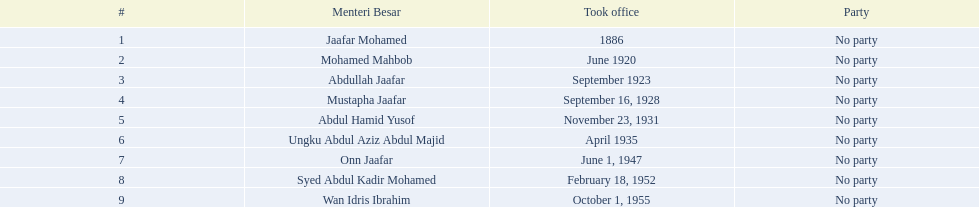What are all the people that were menteri besar of johor? Jaafar Mohamed, Mohamed Mahbob, Abdullah Jaafar, Mustapha Jaafar, Abdul Hamid Yusof, Ungku Abdul Aziz Abdul Majid, Onn Jaafar, Syed Abdul Kadir Mohamed, Wan Idris Ibrahim. Who ruled the longest? Ungku Abdul Aziz Abdul Majid. 